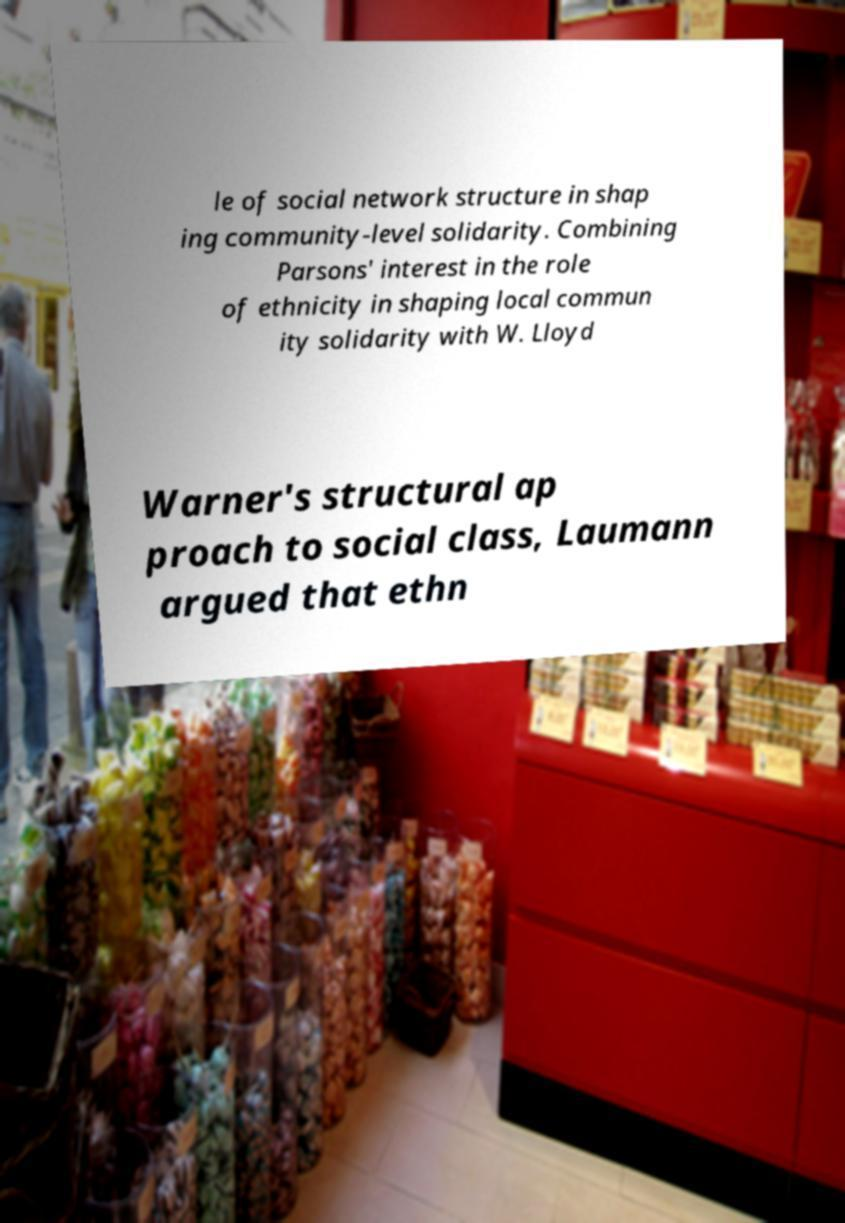Could you extract and type out the text from this image? le of social network structure in shap ing community-level solidarity. Combining Parsons' interest in the role of ethnicity in shaping local commun ity solidarity with W. Lloyd Warner's structural ap proach to social class, Laumann argued that ethn 